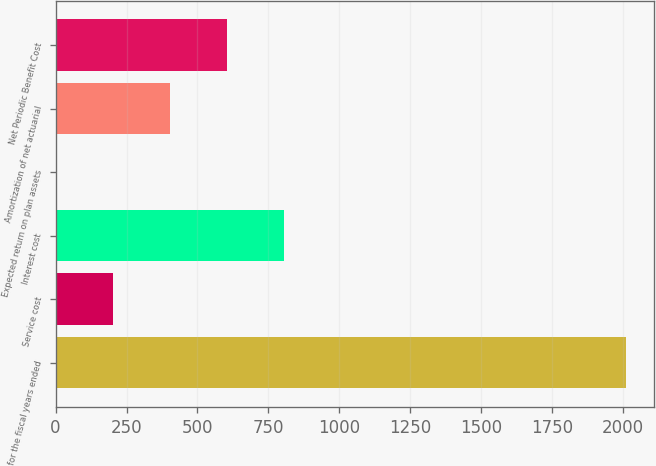<chart> <loc_0><loc_0><loc_500><loc_500><bar_chart><fcel>for the fiscal years ended<fcel>Service cost<fcel>Interest cost<fcel>Expected return on plan assets<fcel>Amortization of net actuarial<fcel>Net Periodic Benefit Cost<nl><fcel>2009<fcel>201.79<fcel>804.19<fcel>0.99<fcel>402.59<fcel>603.39<nl></chart> 